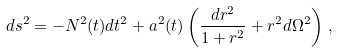Convert formula to latex. <formula><loc_0><loc_0><loc_500><loc_500>d s ^ { 2 } = - N ^ { 2 } ( t ) d t ^ { 2 } + a ^ { 2 } ( t ) \left ( \frac { d r ^ { 2 } } { 1 + r ^ { 2 } } + r ^ { 2 } d \Omega ^ { 2 } \right ) \, ,</formula> 